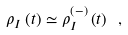<formula> <loc_0><loc_0><loc_500><loc_500>\rho _ { I } \left ( t \right ) \simeq \rho _ { I } ^ { \left ( - \right ) } \left ( t \right ) \ ,</formula> 